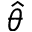<formula> <loc_0><loc_0><loc_500><loc_500>\hat { \theta }</formula> 